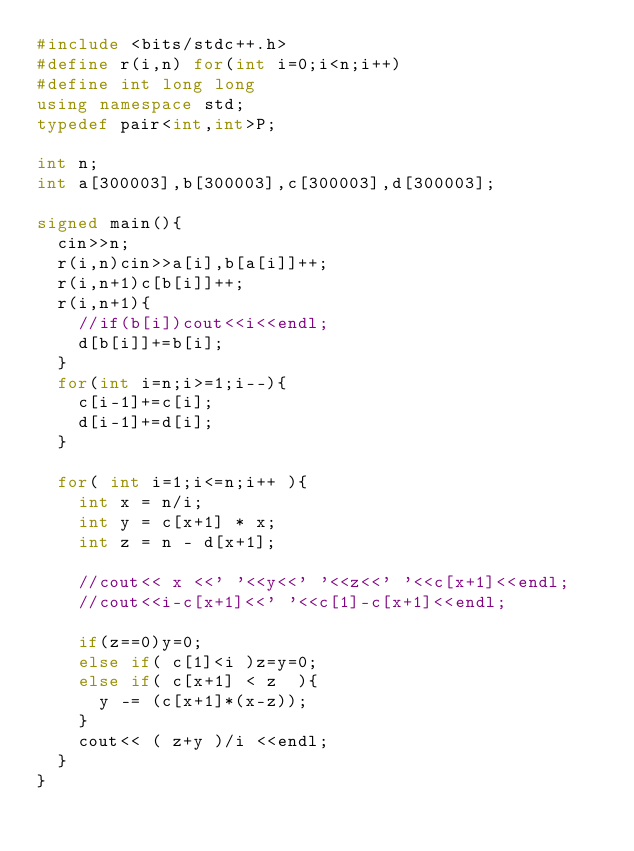<code> <loc_0><loc_0><loc_500><loc_500><_C++_>#include <bits/stdc++.h>
#define r(i,n) for(int i=0;i<n;i++)
#define int long long
using namespace std;
typedef pair<int,int>P;

int n;
int a[300003],b[300003],c[300003],d[300003];

signed main(){
	cin>>n;
	r(i,n)cin>>a[i],b[a[i]]++;
	r(i,n+1)c[b[i]]++;
	r(i,n+1){
		//if(b[i])cout<<i<<endl;
		d[b[i]]+=b[i];
	}
	for(int i=n;i>=1;i--){
		c[i-1]+=c[i];
		d[i-1]+=d[i];
	}

	for( int i=1;i<=n;i++ ){
		int x = n/i;
		int y = c[x+1] * x;
		int z = n - d[x+1];

		//cout<< x <<' '<<y<<' '<<z<<' '<<c[x+1]<<endl;
		//cout<<i-c[x+1]<<' '<<c[1]-c[x+1]<<endl;

		if(z==0)y=0;
		else if( c[1]<i )z=y=0;
		else if( c[x+1] < z  ){
			y -= (c[x+1]*(x-z));
		}
		cout<< ( z+y )/i <<endl;
	}
}
</code> 